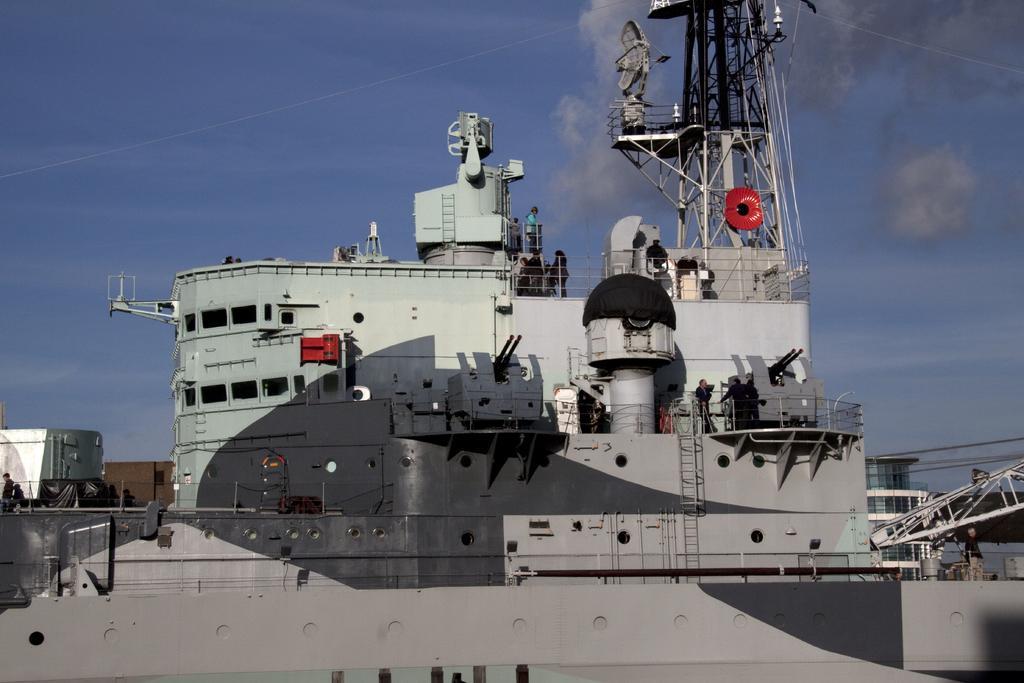Please provide a concise description of this image. In this image I can see a ship. On the ship I can see some people. In the background I can see the sky. Here I can see ladders and tower. 